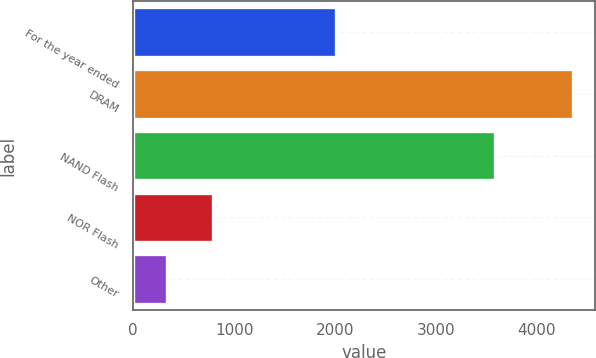Convert chart. <chart><loc_0><loc_0><loc_500><loc_500><bar_chart><fcel>For the year ended<fcel>DRAM<fcel>NAND Flash<fcel>NOR Flash<fcel>Other<nl><fcel>2013<fcel>4361<fcel>3589<fcel>792<fcel>331<nl></chart> 